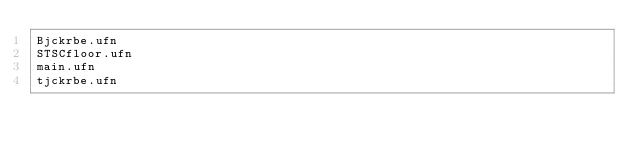Convert code to text. <code><loc_0><loc_0><loc_500><loc_500><_Cuda_>Bjckrbe.ufn
STSCfloor.ufn
main.ufn
tjckrbe.ufn
</code> 